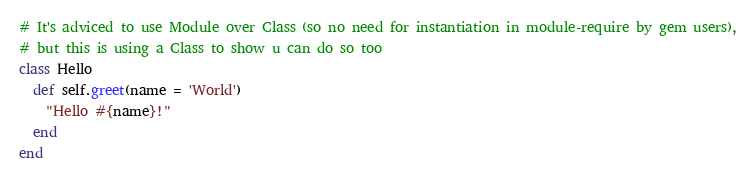<code> <loc_0><loc_0><loc_500><loc_500><_Ruby_># It's adviced to use Module over Class (so no need for instantiation in module-require by gem users),
# but this is using a Class to show u can do so too
class Hello
  def self.greet(name = 'World')
  	"Hello #{name}!"
  end
end</code> 